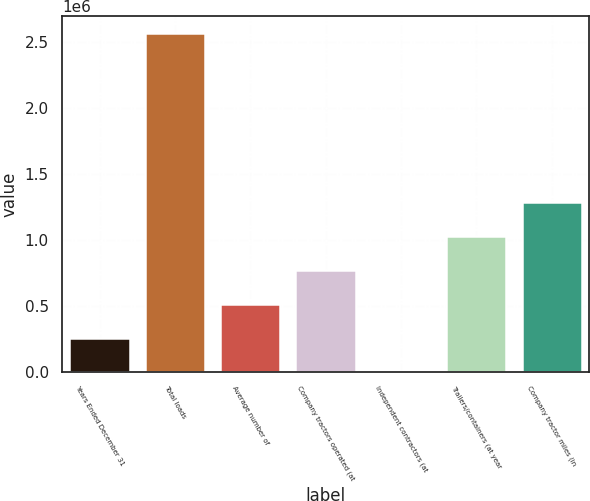Convert chart. <chart><loc_0><loc_0><loc_500><loc_500><bar_chart><fcel>Years Ended December 31<fcel>Total loads<fcel>Average number of<fcel>Company tractors operated (at<fcel>Independent contractors (at<fcel>Trailers/containers (at year<fcel>Company tractor miles (in<nl><fcel>256894<fcel>2.56592e+06<fcel>513452<fcel>770010<fcel>336<fcel>1.02657e+06<fcel>1.28313e+06<nl></chart> 